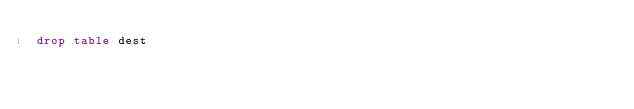Convert code to text. <code><loc_0><loc_0><loc_500><loc_500><_SQL_>drop table dest
</code> 